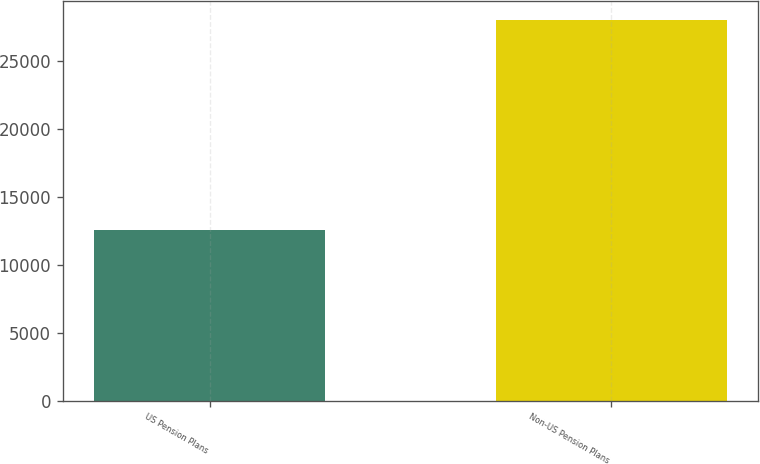Convert chart. <chart><loc_0><loc_0><loc_500><loc_500><bar_chart><fcel>US Pension Plans<fcel>Non-US Pension Plans<nl><fcel>12563<fcel>28023<nl></chart> 